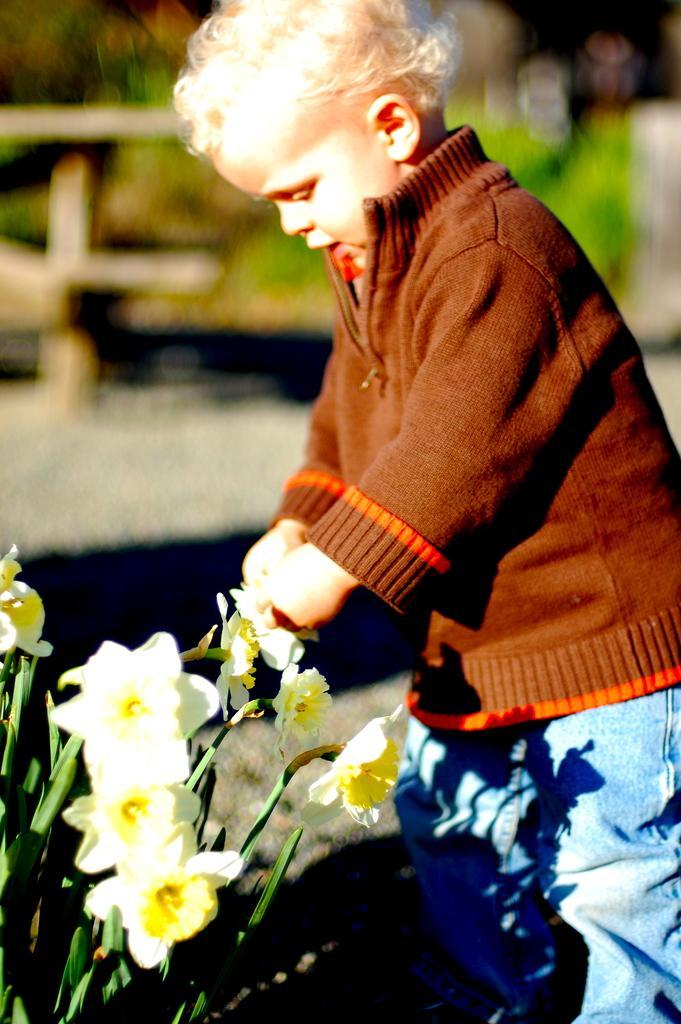Describe this image in one or two sentences. In this image I can see the person with the brown and blue color dress. In-front of the person I can see the flowers to the plants. I can see these flowers are in cream and yellow color. In the background I can see few more plants and the wooden object. And the background is blurred. 